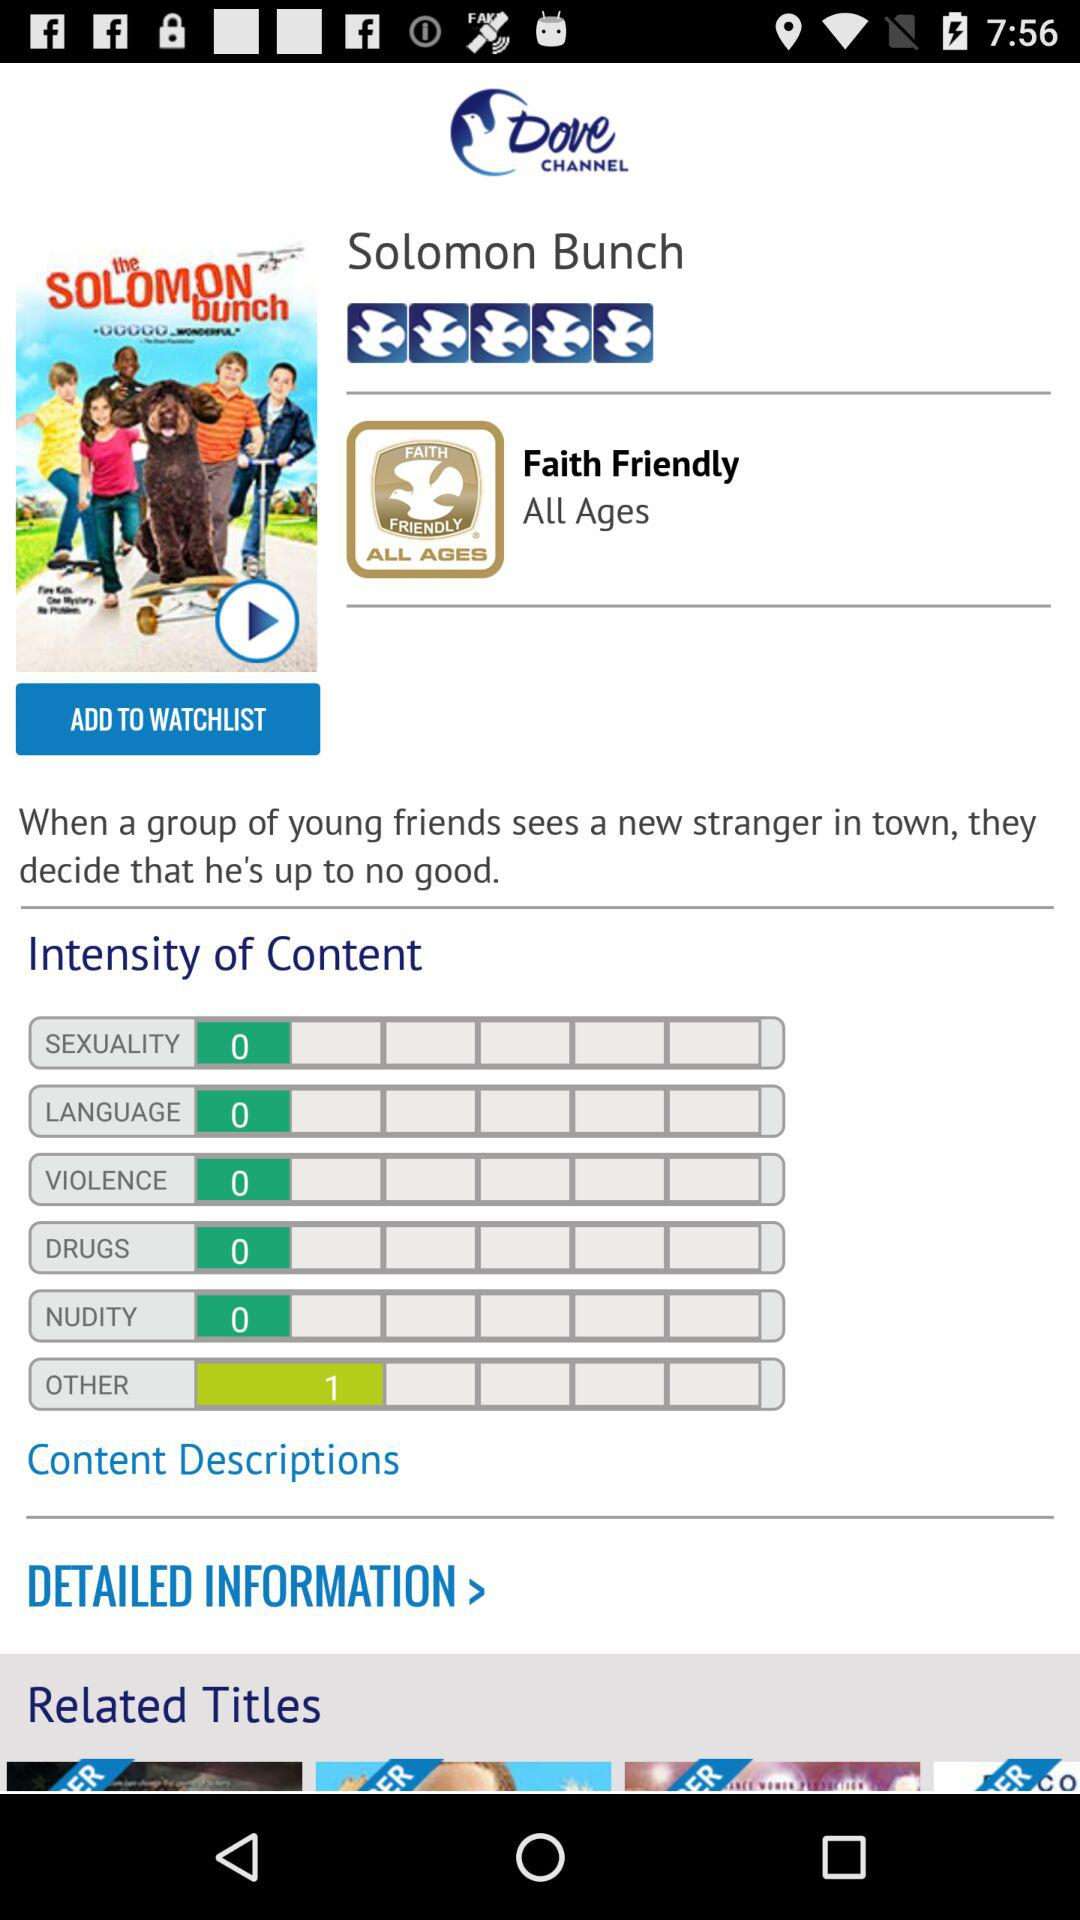What is the title of the movie? The title of the movie is "Solomon Bunch". 